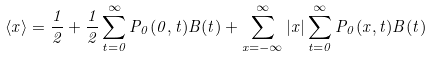Convert formula to latex. <formula><loc_0><loc_0><loc_500><loc_500>\langle x \rangle = \frac { 1 } { 2 } + \frac { 1 } { 2 } \sum _ { t = 0 } ^ { \infty } P _ { 0 } ( 0 , t ) B ( t ) + \sum _ { x = - \infty } ^ { \infty } | x | \sum _ { t = 0 } ^ { \infty } P _ { 0 } ( x , t ) B ( t )</formula> 